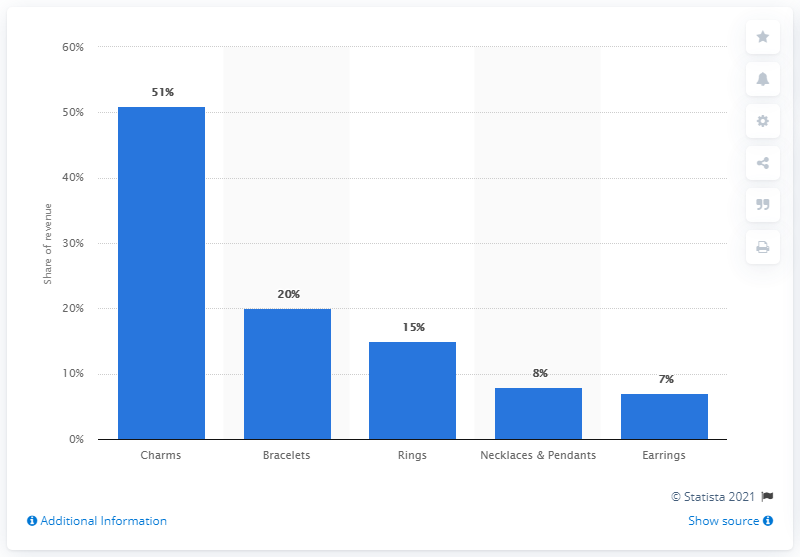Indicate a few pertinent items in this graphic. The earrings do not receive a higher percentage of revenue compared to rings. The product that generates the highest share of revenue is Charms. 